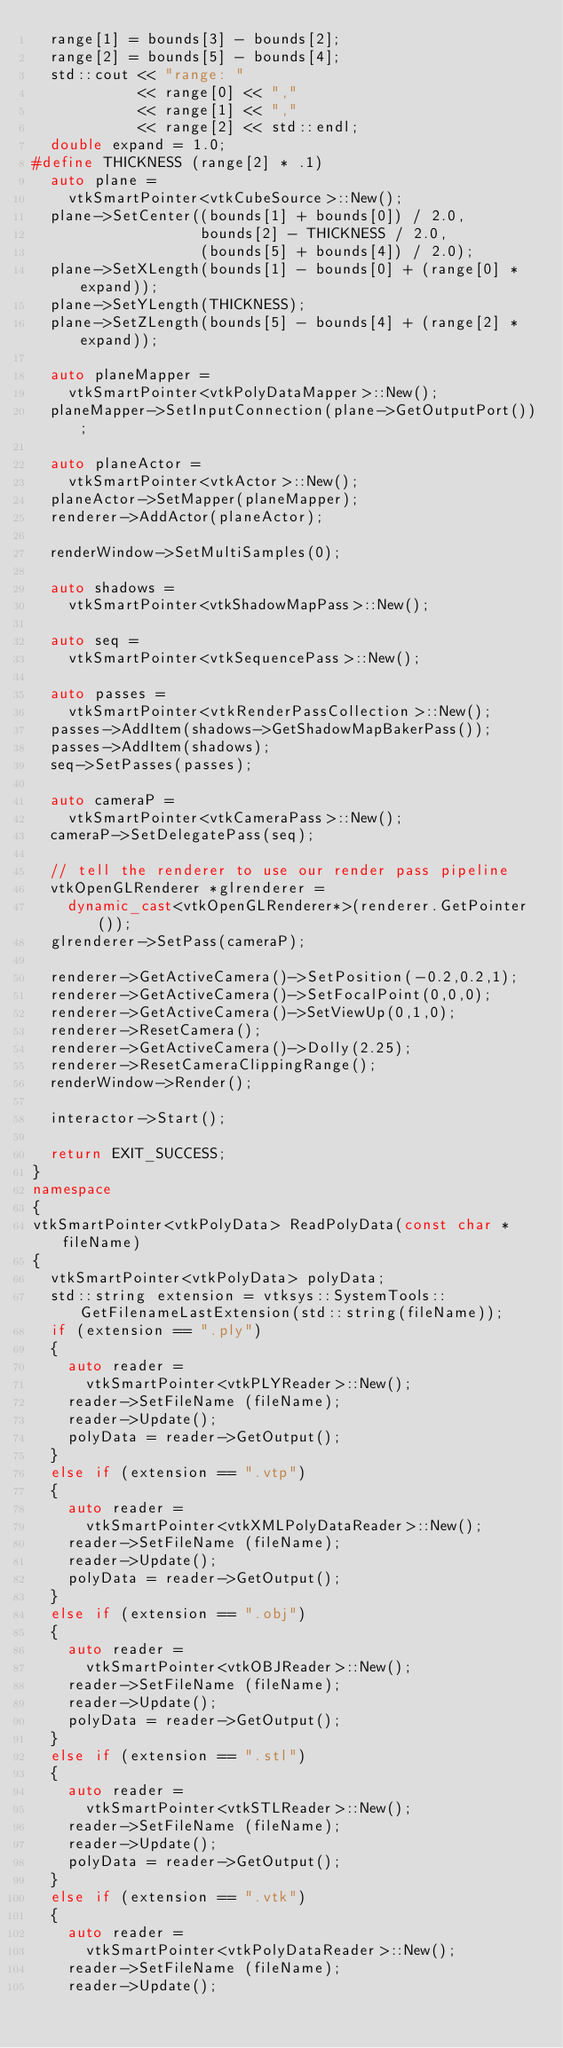Convert code to text. <code><loc_0><loc_0><loc_500><loc_500><_C++_>  range[1] = bounds[3] - bounds[2];
  range[2] = bounds[5] - bounds[4];
  std::cout << "range: "
            << range[0] << "," 
            << range[1] << "," 
            << range[2] << std::endl;
  double expand = 1.0;
#define THICKNESS (range[2] * .1)
  auto plane =
    vtkSmartPointer<vtkCubeSource>::New();
  plane->SetCenter((bounds[1] + bounds[0]) / 2.0,
                   bounds[2] - THICKNESS / 2.0,
                   (bounds[5] + bounds[4]) / 2.0);
  plane->SetXLength(bounds[1] - bounds[0] + (range[0] * expand));
  plane->SetYLength(THICKNESS);
  plane->SetZLength(bounds[5] - bounds[4] + (range[2] * expand));

  auto planeMapper =
    vtkSmartPointer<vtkPolyDataMapper>::New();
  planeMapper->SetInputConnection(plane->GetOutputPort());

  auto planeActor =
    vtkSmartPointer<vtkActor>::New();
  planeActor->SetMapper(planeMapper);
  renderer->AddActor(planeActor);

  renderWindow->SetMultiSamples(0);

  auto shadows =
    vtkSmartPointer<vtkShadowMapPass>::New();

  auto seq =
    vtkSmartPointer<vtkSequencePass>::New();

  auto passes =
    vtkSmartPointer<vtkRenderPassCollection>::New();
  passes->AddItem(shadows->GetShadowMapBakerPass());
  passes->AddItem(shadows);
  seq->SetPasses(passes);

  auto cameraP =
    vtkSmartPointer<vtkCameraPass>::New();
  cameraP->SetDelegatePass(seq);

  // tell the renderer to use our render pass pipeline
  vtkOpenGLRenderer *glrenderer =
    dynamic_cast<vtkOpenGLRenderer*>(renderer.GetPointer());
  glrenderer->SetPass(cameraP);

  renderer->GetActiveCamera()->SetPosition(-0.2,0.2,1);
  renderer->GetActiveCamera()->SetFocalPoint(0,0,0);
  renderer->GetActiveCamera()->SetViewUp(0,1,0);
  renderer->ResetCamera();
  renderer->GetActiveCamera()->Dolly(2.25);
  renderer->ResetCameraClippingRange();
  renderWindow->Render();

  interactor->Start();

  return EXIT_SUCCESS;
}
namespace
{
vtkSmartPointer<vtkPolyData> ReadPolyData(const char *fileName)
{
  vtkSmartPointer<vtkPolyData> polyData;
  std::string extension = vtksys::SystemTools::GetFilenameLastExtension(std::string(fileName));
  if (extension == ".ply")
  {
    auto reader =
      vtkSmartPointer<vtkPLYReader>::New();
    reader->SetFileName (fileName);
    reader->Update();
    polyData = reader->GetOutput();
  }
  else if (extension == ".vtp")
  {
    auto reader =
      vtkSmartPointer<vtkXMLPolyDataReader>::New();
    reader->SetFileName (fileName);
    reader->Update();
    polyData = reader->GetOutput();
  }
  else if (extension == ".obj")
  {
    auto reader =
      vtkSmartPointer<vtkOBJReader>::New();
    reader->SetFileName (fileName);
    reader->Update();
    polyData = reader->GetOutput();
  }
  else if (extension == ".stl")
  {
    auto reader =
      vtkSmartPointer<vtkSTLReader>::New();
    reader->SetFileName (fileName);
    reader->Update();
    polyData = reader->GetOutput();
  }
  else if (extension == ".vtk")
  {
    auto reader =
      vtkSmartPointer<vtkPolyDataReader>::New();
    reader->SetFileName (fileName);
    reader->Update();</code> 